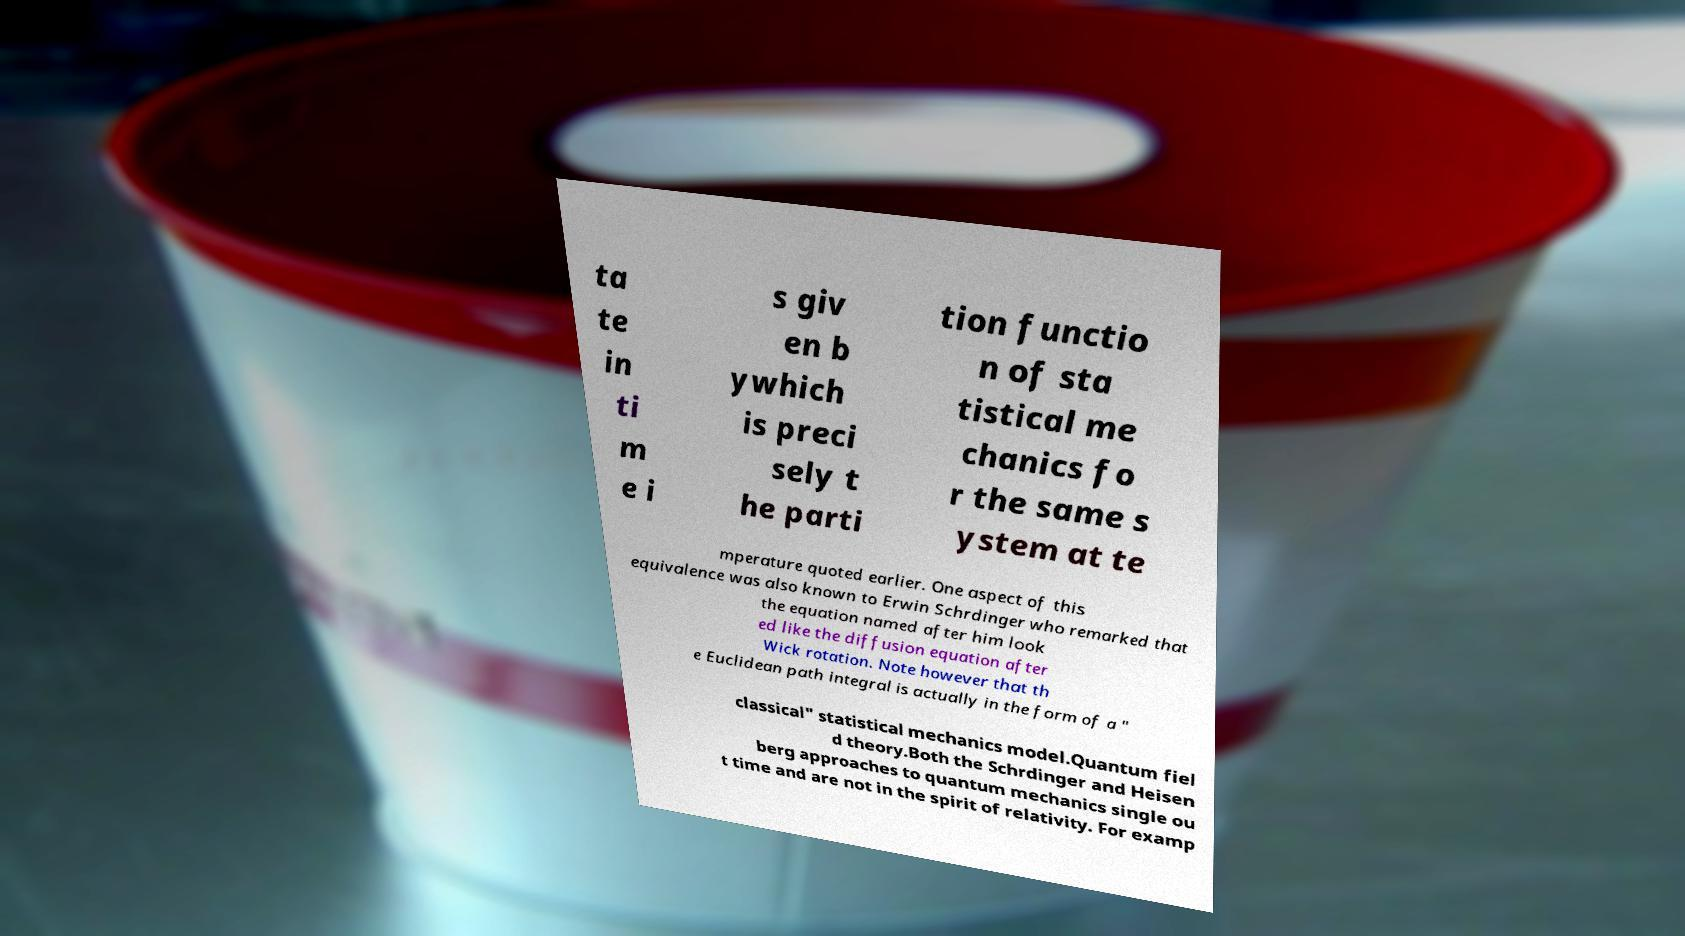Please read and relay the text visible in this image. What does it say? ta te in ti m e i s giv en b ywhich is preci sely t he parti tion functio n of sta tistical me chanics fo r the same s ystem at te mperature quoted earlier. One aspect of this equivalence was also known to Erwin Schrdinger who remarked that the equation named after him look ed like the diffusion equation after Wick rotation. Note however that th e Euclidean path integral is actually in the form of a " classical" statistical mechanics model.Quantum fiel d theory.Both the Schrdinger and Heisen berg approaches to quantum mechanics single ou t time and are not in the spirit of relativity. For examp 